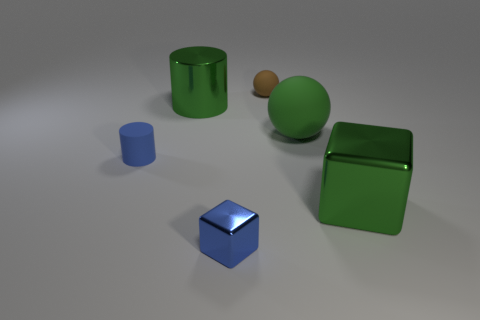How many other things are there of the same material as the brown thing?
Offer a very short reply. 2. How many things are big green metal objects that are in front of the big matte thing or rubber cylinders?
Keep it short and to the point. 2. The green object on the left side of the small matte thing behind the tiny blue cylinder is what shape?
Keep it short and to the point. Cylinder. Does the big metal object that is right of the small ball have the same shape as the tiny brown thing?
Provide a succinct answer. No. The big object that is on the left side of the large ball is what color?
Provide a short and direct response. Green. What number of blocks are tiny metal objects or green things?
Offer a terse response. 2. There is a cube that is in front of the metallic block that is behind the small blue block; what is its size?
Your response must be concise. Small. There is a large shiny block; is its color the same as the tiny matte thing that is on the left side of the brown matte ball?
Ensure brevity in your answer.  No. What number of small matte cylinders are behind the green cylinder?
Offer a terse response. 0. Are there fewer small spheres than tiny green things?
Your answer should be compact. No. 